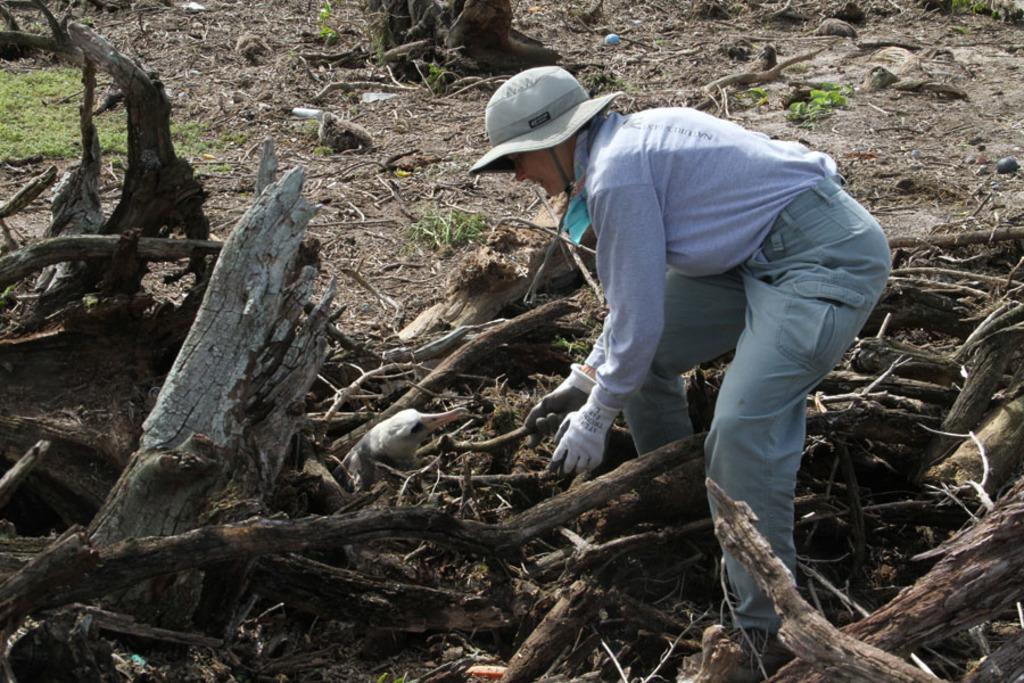What is the man wearing on his head in the image? The man is wearing a cap in the image. Where is the man located in the image? The man is on the right side of the image. What type of objects are present among the dry wooden sticks? There are no objects mentioned among the dry wooden sticks; only the sticks themselves are mentioned. What type of animal can be seen at the bottom of the image? There is an animal at the bottom of the image, but its specific type is not mentioned in the provided facts. What type of shirt is the crow wearing in the image? There is no crow or shirt present in the image. What act is the man performing with the wooden sticks in the image? The provided facts do not mention any act being performed by the man with the wooden sticks. 